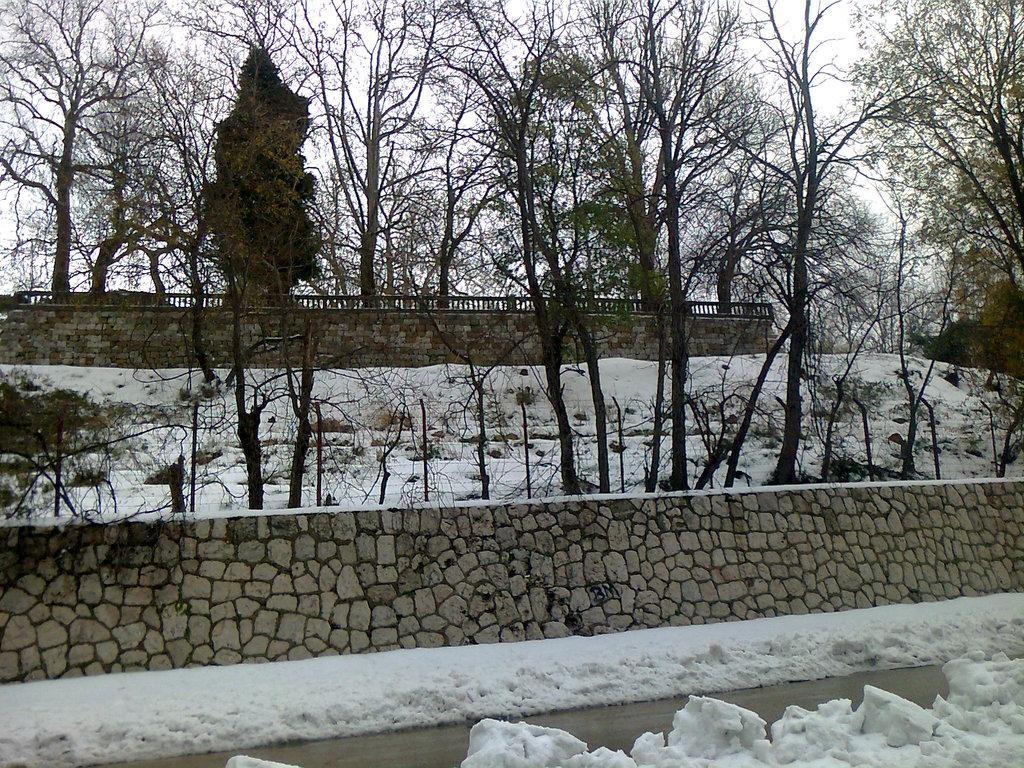In one or two sentences, can you explain what this image depicts? In this image I can see the snow and the wall. In the background I can see many trees, railing and the sky. 